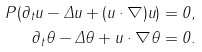<formula> <loc_0><loc_0><loc_500><loc_500>P ( \partial _ { t } u - \Delta u + ( u \cdot \nabla ) u ) = 0 , \\ \partial _ { t } \theta - \Delta \theta + u \cdot \nabla \theta = 0 .</formula> 